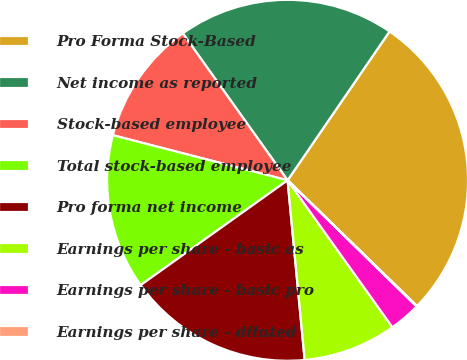Convert chart to OTSL. <chart><loc_0><loc_0><loc_500><loc_500><pie_chart><fcel>Pro Forma Stock-Based<fcel>Net income as reported<fcel>Stock-based employee<fcel>Total stock-based employee<fcel>Pro forma net income<fcel>Earnings per share - basic as<fcel>Earnings per share - basic pro<fcel>Earnings per share - diluted<nl><fcel>27.71%<fcel>19.42%<fcel>11.12%<fcel>13.88%<fcel>16.65%<fcel>8.35%<fcel>2.82%<fcel>0.05%<nl></chart> 